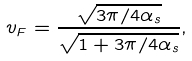Convert formula to latex. <formula><loc_0><loc_0><loc_500><loc_500>v _ { F } = \frac { \sqrt { 3 \pi / 4 \alpha _ { s } } } { \sqrt { 1 + 3 \pi / 4 \alpha _ { s } } } ,</formula> 